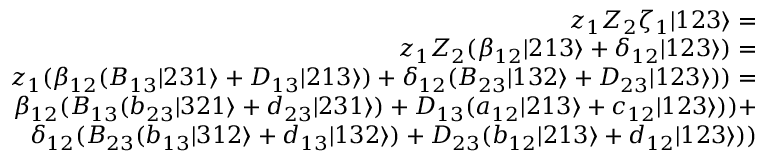Convert formula to latex. <formula><loc_0><loc_0><loc_500><loc_500>\begin{array} { r l r } & { z _ { 1 } Z _ { 2 } \zeta _ { 1 } | 1 2 3 \rangle = } \\ & { z _ { 1 } Z _ { 2 } ( \beta _ { 1 2 } | 2 1 3 \rangle + \delta _ { 1 2 } | 1 2 3 \rangle ) = } \\ & { z _ { 1 } ( \beta _ { 1 2 } ( B _ { 1 3 } | 2 3 1 \rangle + D _ { 1 3 } | 2 1 3 \rangle ) + \delta _ { 1 2 } ( B _ { 2 3 } | 1 3 2 \rangle + D _ { 2 3 } | 1 2 3 \rangle ) ) = } \\ & { \beta _ { 1 2 } ( B _ { 1 3 } ( b _ { 2 3 } | 3 2 1 \rangle + d _ { 2 3 } | 2 3 1 \rangle ) + D _ { 1 3 } ( a _ { 1 2 } | 2 1 3 \rangle + c _ { 1 2 } | 1 2 3 \rangle ) ) + } \\ & { \delta _ { 1 2 } ( B _ { 2 3 } ( b _ { 1 3 } | 3 1 2 \rangle + d _ { 1 3 } | 1 3 2 \rangle ) + D _ { 2 3 } ( b _ { 1 2 } | 2 1 3 \rangle + d _ { 1 2 } | 1 2 3 \rangle ) ) } \end{array}</formula> 